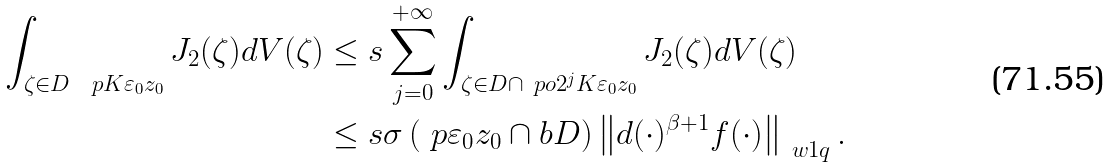Convert formula to latex. <formula><loc_0><loc_0><loc_500><loc_500>\int _ { \zeta \in D \ \ p { K \varepsilon _ { 0 } } { z _ { 0 } } } J _ { 2 } ( \zeta ) d V ( \zeta ) & \leq s \sum _ { j = 0 } ^ { + \infty } \int _ { \zeta \in D \cap \ p o { 2 ^ { j } K \varepsilon _ { 0 } } { z _ { 0 } } } J _ { 2 } ( \zeta ) d V ( \zeta ) \\ & \leq s { \sigma \left ( \ p { \varepsilon _ { 0 } } { z _ { 0 } } \cap b D \right ) } \left \| d ( \cdot ) ^ { \beta + 1 } f ( \cdot ) \right \| _ { \ w 1 q } .</formula> 